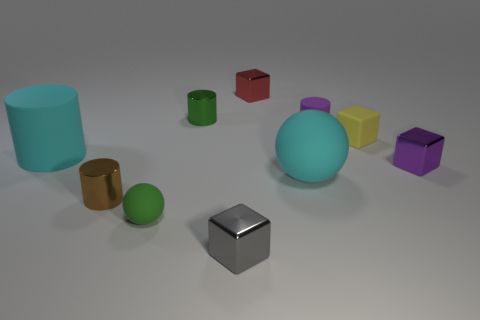The cyan matte object that is the same shape as the brown metallic thing is what size?
Make the answer very short. Large. What is the size of the rubber cylinder on the left side of the tiny green object that is on the left side of the green cylinder?
Your answer should be compact. Large. What is the material of the large cylinder?
Provide a succinct answer. Rubber. What color is the tiny ball that is made of the same material as the big cyan cylinder?
Your answer should be very brief. Green. Are the tiny purple block and the large cyan object behind the big rubber ball made of the same material?
Offer a very short reply. No. What number of small red objects have the same material as the gray thing?
Your answer should be very brief. 1. What is the shape of the tiny rubber thing in front of the purple cube?
Give a very brief answer. Sphere. Do the thing that is on the left side of the brown cylinder and the small block left of the small red thing have the same material?
Offer a very short reply. No. Is there a small purple metal object of the same shape as the tiny yellow thing?
Keep it short and to the point. Yes. How many things are green things behind the purple cube or green metallic cylinders?
Your response must be concise. 1. 